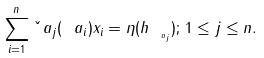<formula> <loc_0><loc_0><loc_500><loc_500>\sum _ { i = 1 } ^ { n } \check { \ } a _ { j } ( \ a _ { i } ) x _ { i } = \eta ( h _ { _ { \ a _ { j } } } ) ; \, 1 \leq j \leq n .</formula> 